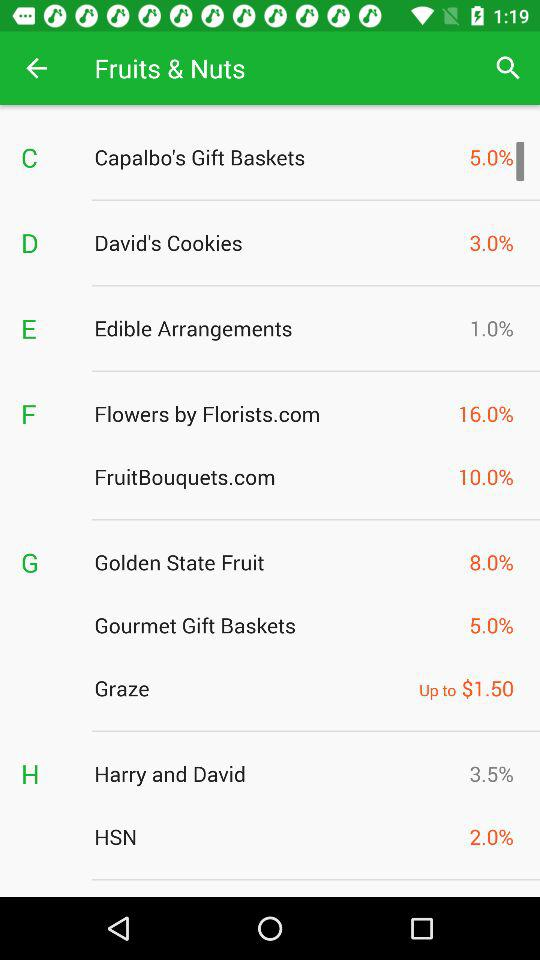Which company has the lowest commission rate, Graze or Flowers by Florists.com?
Answer the question using a single word or phrase. Graze 